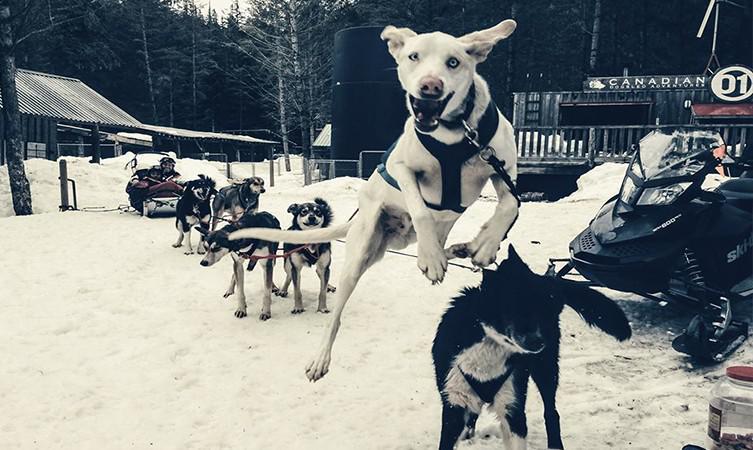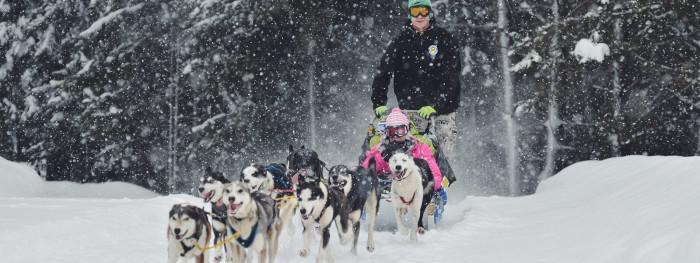The first image is the image on the left, the second image is the image on the right. Considering the images on both sides, is "One image shows one dog sled team being led by a man in a red jacket." valid? Answer yes or no. No. The first image is the image on the left, the second image is the image on the right. Analyze the images presented: Is the assertion "The right image has a man on a sled with a red jacket" valid? Answer yes or no. No. 